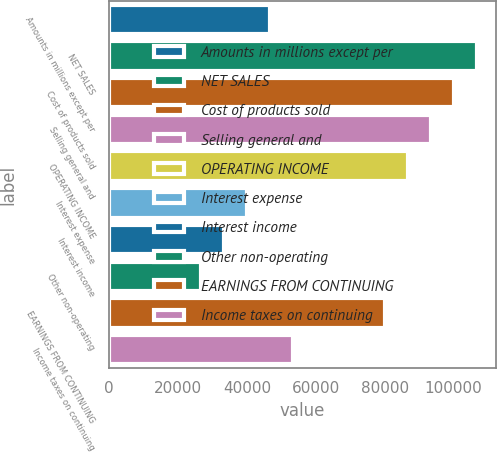<chart> <loc_0><loc_0><loc_500><loc_500><bar_chart><fcel>Amounts in millions except per<fcel>NET SALES<fcel>Cost of products sold<fcel>Selling general and<fcel>OPERATING INCOME<fcel>Interest expense<fcel>Interest income<fcel>Other non-operating<fcel>EARNINGS FROM CONTINUING<fcel>Income taxes on continuing<nl><fcel>46783.5<fcel>106929<fcel>100246<fcel>93563.3<fcel>86880.5<fcel>40100.7<fcel>33417.8<fcel>26735<fcel>80197.6<fcel>53466.3<nl></chart> 